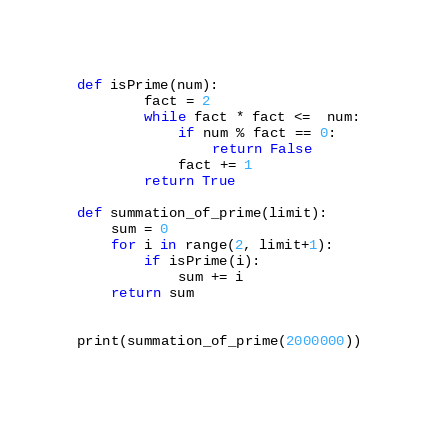<code> <loc_0><loc_0><loc_500><loc_500><_Python_>def isPrime(num):
        fact = 2
        while fact * fact <=  num:
            if num % fact == 0:
                return False
            fact += 1
        return True

def summation_of_prime(limit):
    sum = 0 
    for i in range(2, limit+1):
        if isPrime(i):
            sum += i
    return sum


print(summation_of_prime(2000000))</code> 